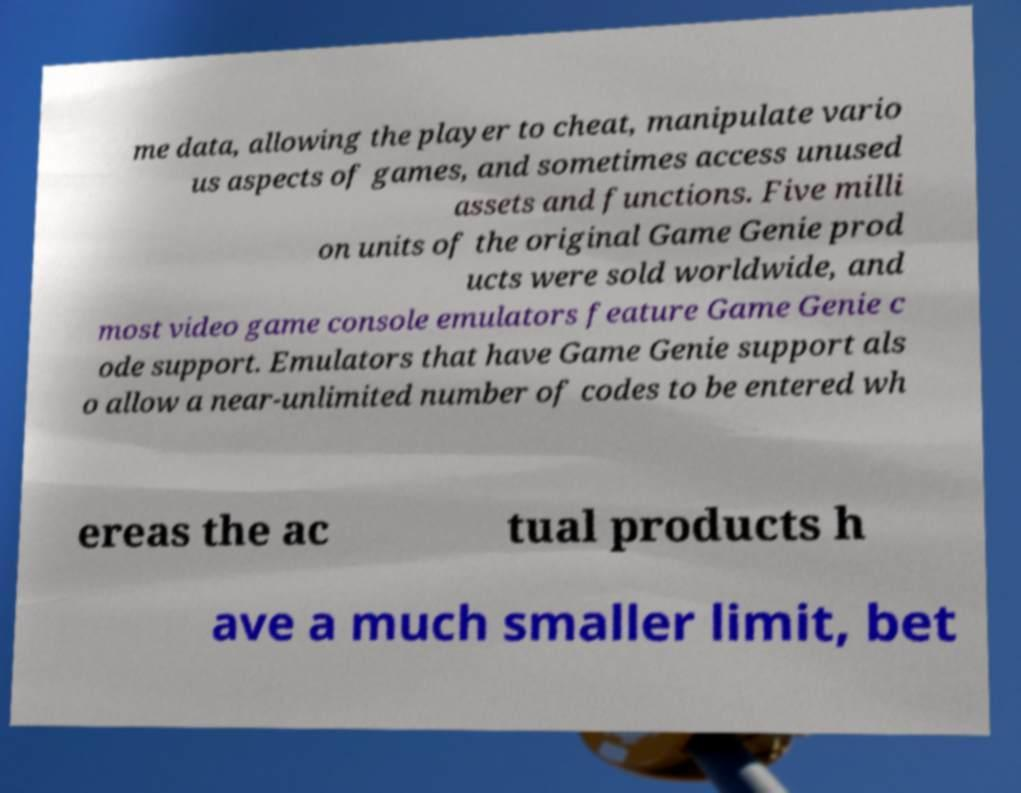Could you assist in decoding the text presented in this image and type it out clearly? me data, allowing the player to cheat, manipulate vario us aspects of games, and sometimes access unused assets and functions. Five milli on units of the original Game Genie prod ucts were sold worldwide, and most video game console emulators feature Game Genie c ode support. Emulators that have Game Genie support als o allow a near-unlimited number of codes to be entered wh ereas the ac tual products h ave a much smaller limit, bet 